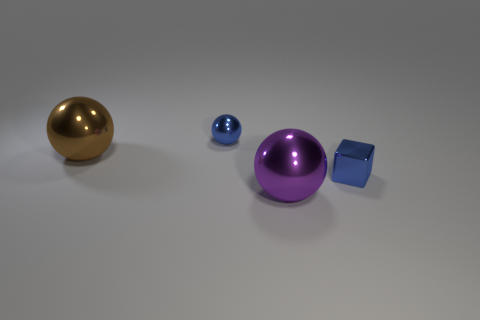Are the tiny thing to the left of the blue cube and the cube to the right of the purple thing made of the same material?
Your response must be concise. Yes. There is a small metallic object that is behind the big metallic thing that is on the left side of the purple shiny thing; what number of tiny metal objects are on the right side of it?
Keep it short and to the point. 1. Does the thing behind the brown sphere have the same color as the small metallic object that is in front of the brown thing?
Offer a very short reply. Yes. Are there any other things of the same color as the cube?
Provide a succinct answer. Yes. There is a large object that is in front of the small metal thing to the right of the purple metallic thing; what color is it?
Provide a short and direct response. Purple. Is there a large matte sphere?
Keep it short and to the point. No. The object that is on the right side of the large brown sphere and to the left of the purple metal thing is what color?
Ensure brevity in your answer.  Blue. There is a cube that is in front of the brown sphere; is its size the same as the thing behind the big brown ball?
Your answer should be compact. Yes. What number of other objects are there of the same size as the brown metallic sphere?
Provide a short and direct response. 1. There is a tiny blue shiny thing on the left side of the purple metallic ball; how many blue metal objects are to the right of it?
Provide a short and direct response. 1. 